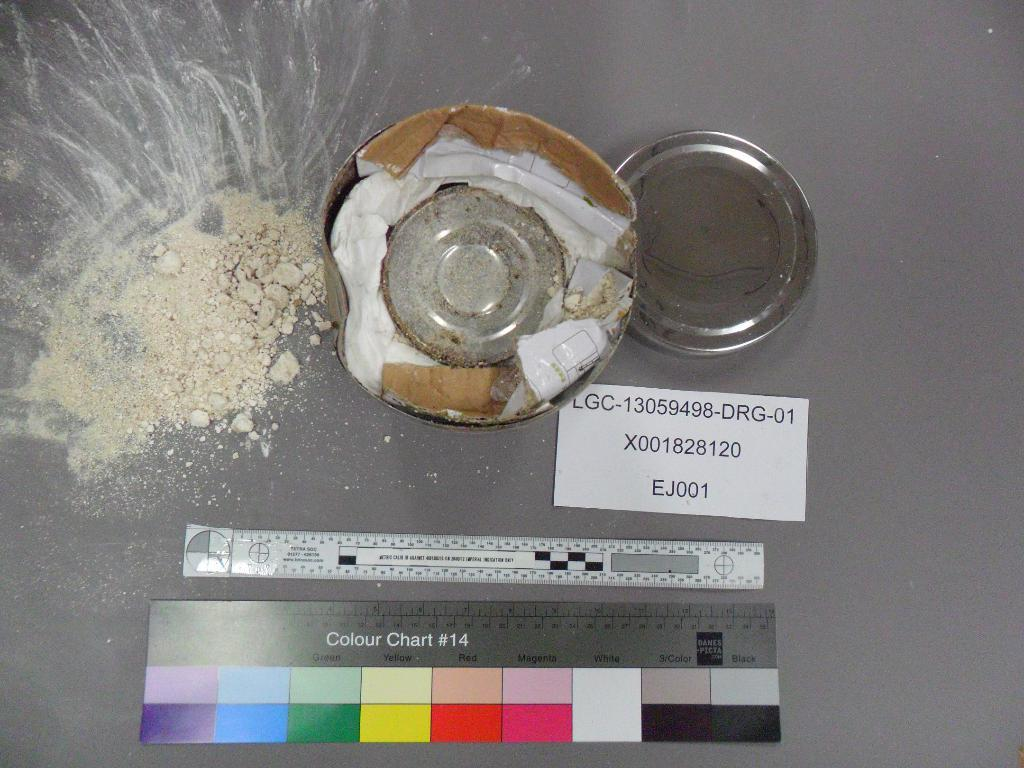<image>
Offer a succinct explanation of the picture presented. a colour chart with many colors under some round item 